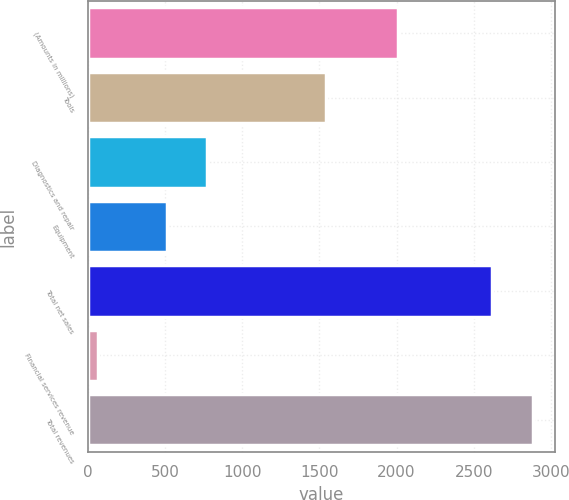Convert chart to OTSL. <chart><loc_0><loc_0><loc_500><loc_500><bar_chart><fcel>(Amounts in millions)<fcel>Tools<fcel>Diagnostics and repair<fcel>Equipment<fcel>Total net sales<fcel>Financial services revenue<fcel>Total revenues<nl><fcel>2010<fcel>1545.1<fcel>772.72<fcel>510.8<fcel>2619.2<fcel>62.3<fcel>2881.12<nl></chart> 